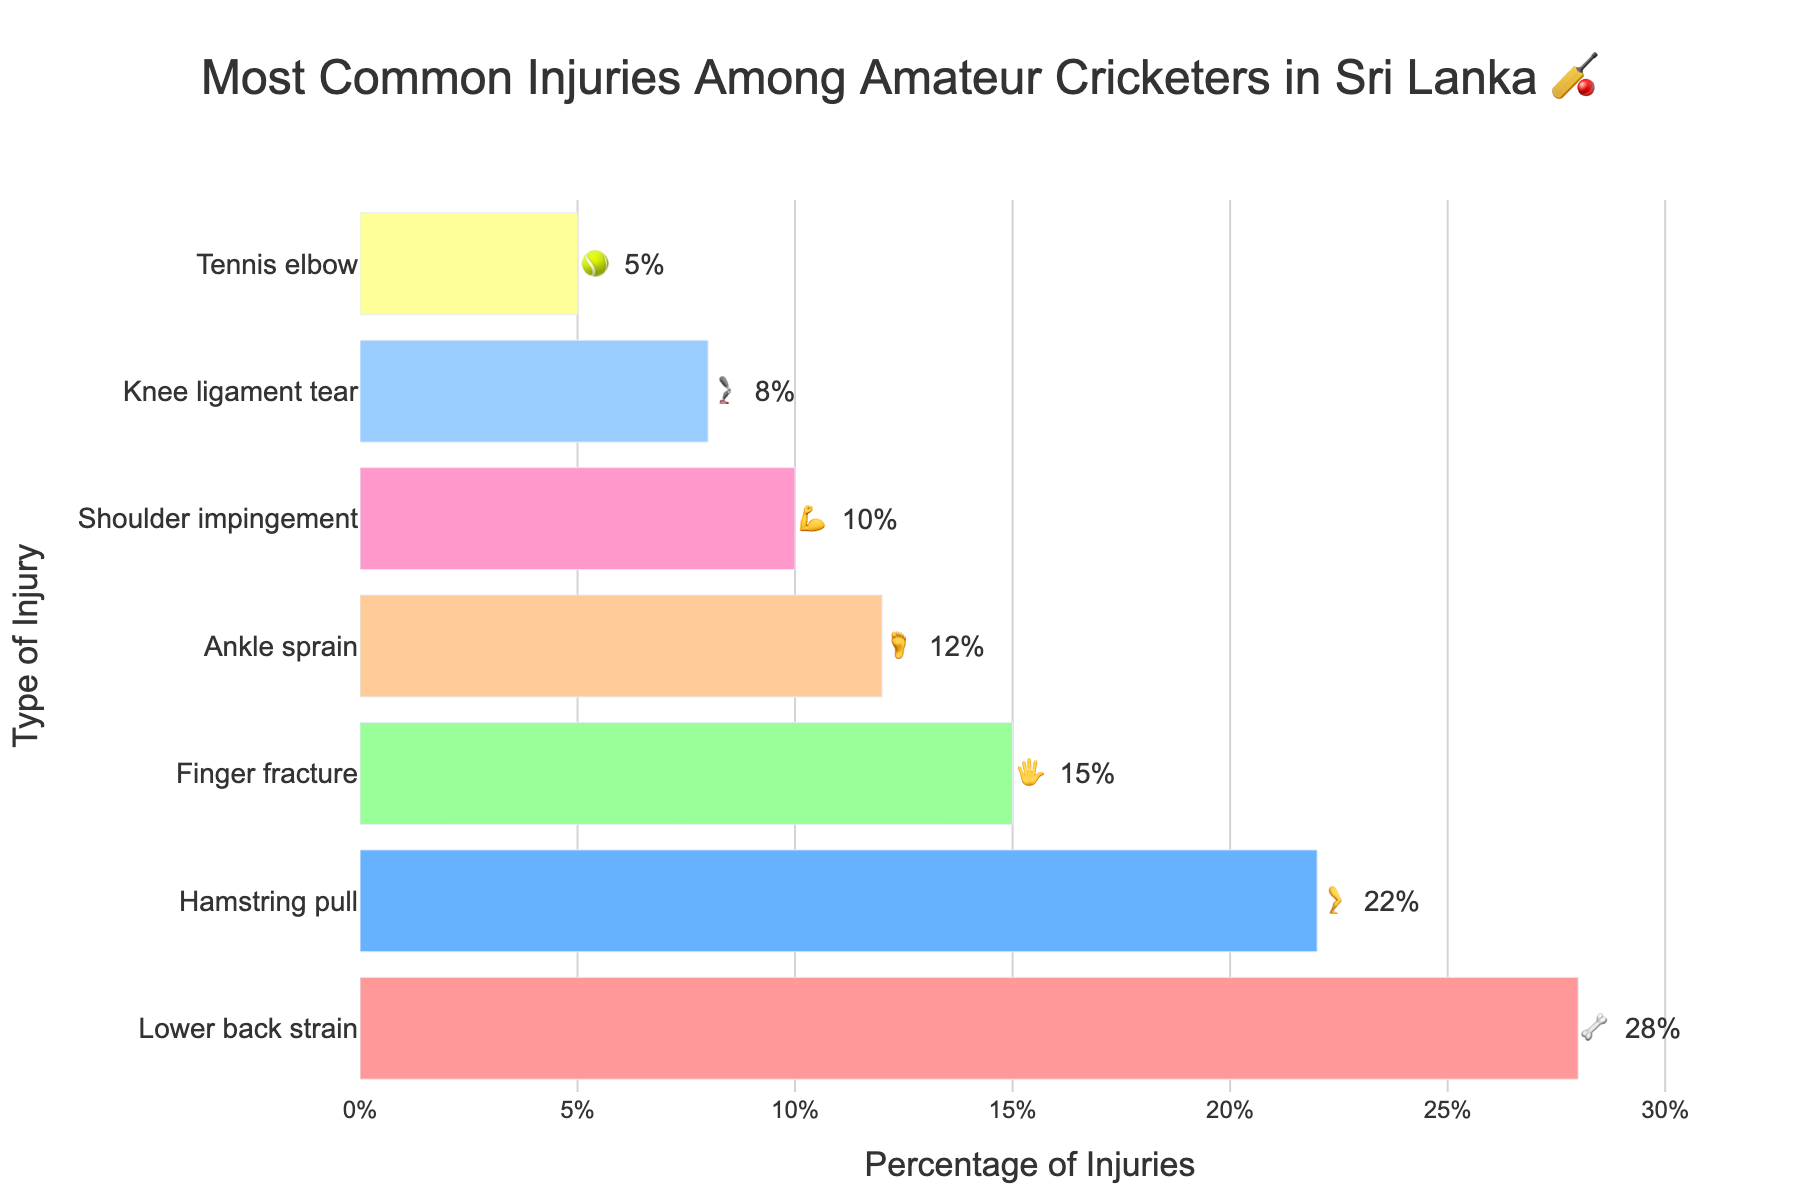what is the title of the chart? The chart's title is displayed at the top of the figure, which provides a description of the data presented. The title reads "Most Common Injuries Among Amateur Cricketers in Sri Lanka 🏏".
Answer: Most Common Injuries Among Amateur Cricketers in Sri Lanka 🏏 What is the most common injury reported by amateur cricketers in Sri Lanka, and what is its percentage? The most common injury is the one with the highest percentage. According to the figure, the highest bar corresponds to "Lower back strain" with a percentage of 28%.
Answer: Lower back strain, 28% Which injury has the least percentage of occurrence, and what is that percentage? To find the least common injury, we look for the shortest bar on the figure. The shortest bar corresponds to "Tennis elbow" with a percentage of 5%.
Answer: Tennis elbow, 5% How many more percentage points does "Lower back strain 🦴" have compared to "Hamstring pull 🦵"? We need to subtract the percentage of "Hamstring pull 🦵" from "Lower back strain 🦴". The values are 28% and 22%, respectively. So, 28% - 22% = 6%.
Answer: 6% What is the combined percentage of injuries for "Ankle sprain 🦶" and "Knee ligament tear 🦿"? We need to add the percentages of "Ankle sprain 🦶" and "Knee ligament tear 🦿". These percentages are 12% and 8%, respectively. So, 12% + 8% = 20%.
Answer: 20% Which injuries have percentages greater than 10%? We identify the injuries with bars extending beyond the 10% mark. These are "Lower back strain 🦴" (28%), "Hamstring pull 🦵" (22%), "Finger fracture 🖐️" (15%), and "Ankle sprain 🦶" (12%).
Answer: Lower back strain, Hamstring pull, Finger fracture, Ankle sprain Are there more injuries with a percentage greater than 20% or less than 10%? We count the injuries: greater than 20% includes "Lower back strain" and "Hamstring pull" (2 injuries), while less than 10% includes "Knee ligament tear" and "Tennis elbow" (2 injuries). Both counts are equal, meaning 2 injuries each.
Answer: Equal, 2 each What is the total percentage of all injuries combined? Sum up the percentages of all injuries listed in the chart: 28% + 22% + 15% + 12% + 10% + 8% + 5% = 100%.
Answer: 100% Which injury symbolized by the emoji 💪 has what percentage? The emoji 💪 represents "Shoulder impingement" which shows a percentage of 10%.
Answer: Shoulder impingement, 10% 